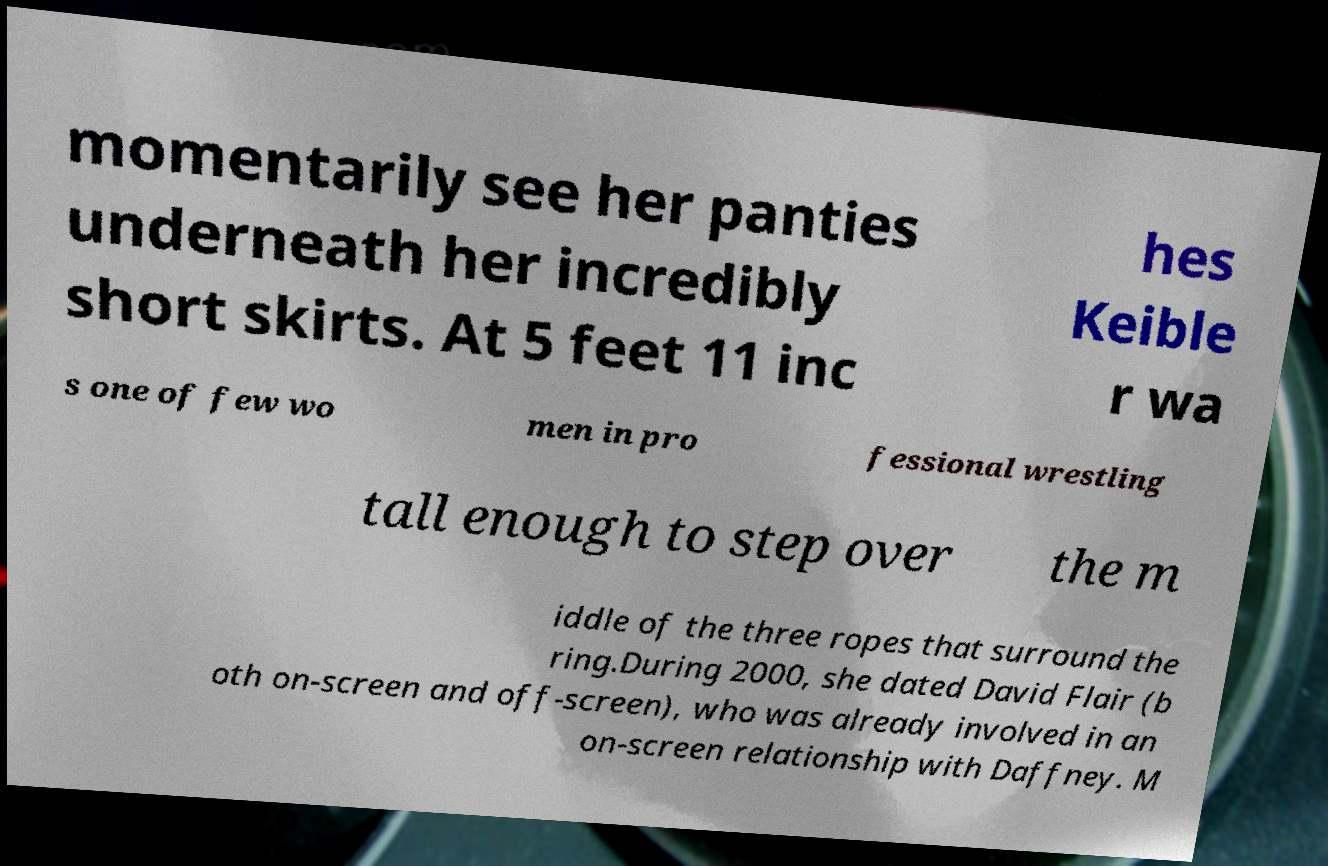For documentation purposes, I need the text within this image transcribed. Could you provide that? momentarily see her panties underneath her incredibly short skirts. At 5 feet 11 inc hes Keible r wa s one of few wo men in pro fessional wrestling tall enough to step over the m iddle of the three ropes that surround the ring.During 2000, she dated David Flair (b oth on-screen and off-screen), who was already involved in an on-screen relationship with Daffney. M 